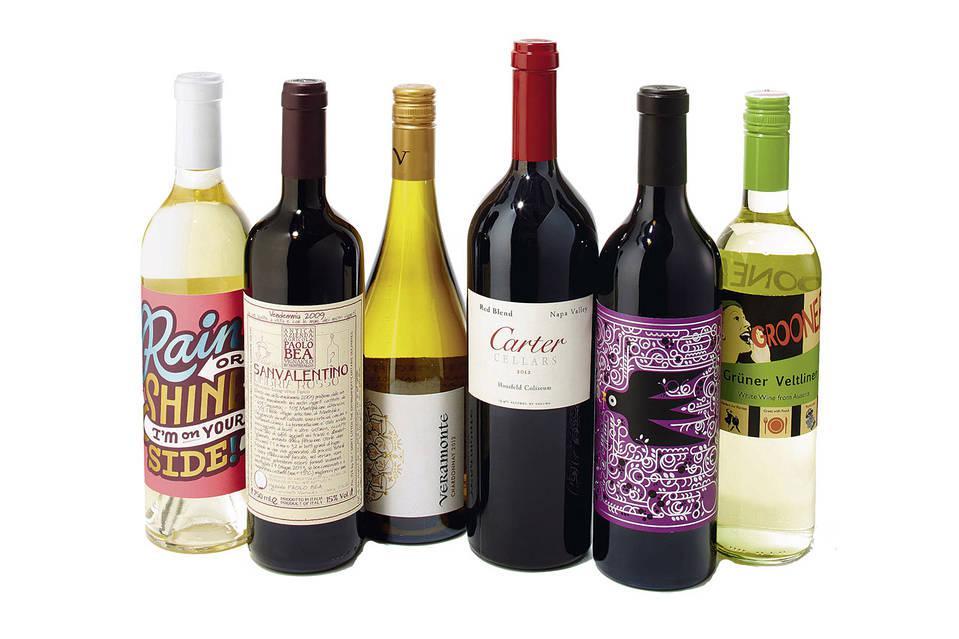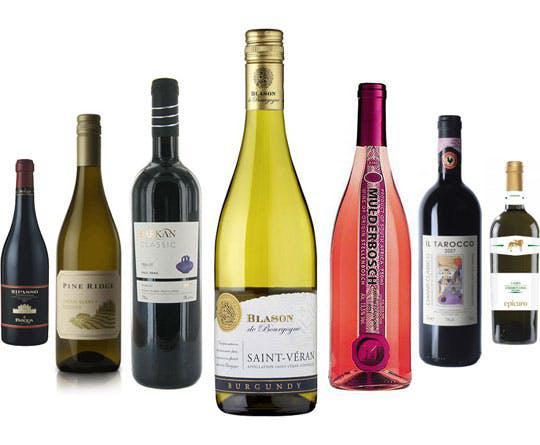The first image is the image on the left, the second image is the image on the right. Considering the images on both sides, is "The image on the left has a bottle of red colored wine sitting in the center of a group of 5 wine bottles." valid? Answer yes or no. No. The first image is the image on the left, the second image is the image on the right. Examine the images to the left and right. Is the description "An image shows bottles arranged with the center one closest to the camera, and no bottles touching or identical." accurate? Answer yes or no. Yes. 